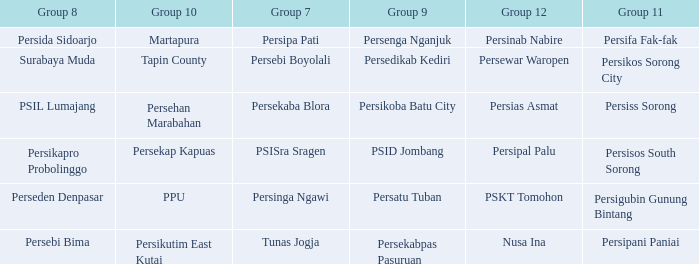Who played in group 8 when Persinab Nabire played in Group 12? Persida Sidoarjo. 